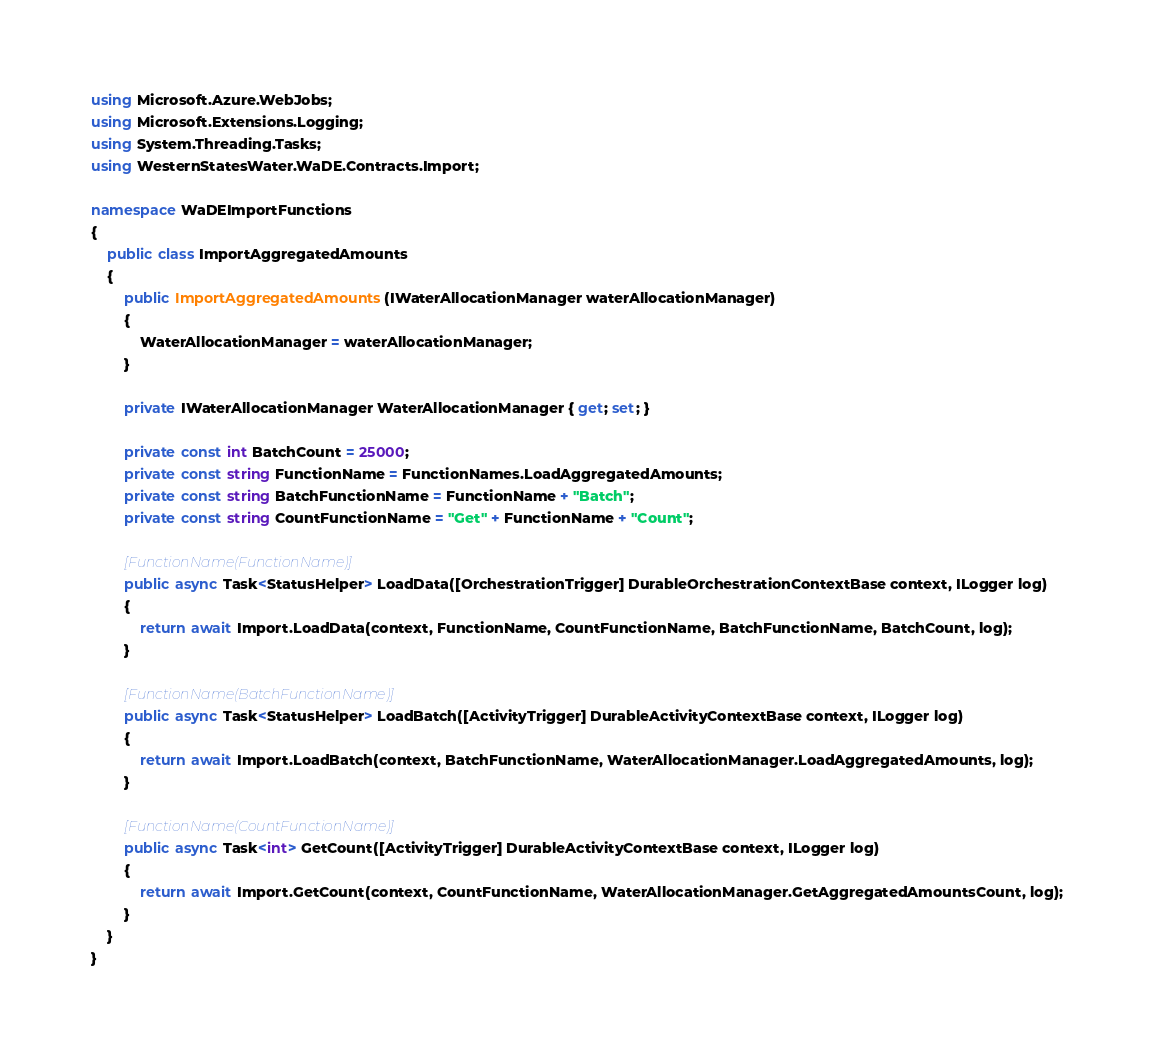Convert code to text. <code><loc_0><loc_0><loc_500><loc_500><_C#_>using Microsoft.Azure.WebJobs;
using Microsoft.Extensions.Logging;
using System.Threading.Tasks;
using WesternStatesWater.WaDE.Contracts.Import;

namespace WaDEImportFunctions
{
    public class ImportAggregatedAmounts
    {
        public ImportAggregatedAmounts(IWaterAllocationManager waterAllocationManager)
        {
            WaterAllocationManager = waterAllocationManager;
        }

        private IWaterAllocationManager WaterAllocationManager { get; set; }
        
        private const int BatchCount = 25000;
        private const string FunctionName = FunctionNames.LoadAggregatedAmounts;
        private const string BatchFunctionName = FunctionName + "Batch";
        private const string CountFunctionName = "Get" + FunctionName + "Count";

        [FunctionName(FunctionName)]
        public async Task<StatusHelper> LoadData([OrchestrationTrigger] DurableOrchestrationContextBase context, ILogger log)
        {
            return await Import.LoadData(context, FunctionName, CountFunctionName, BatchFunctionName, BatchCount, log);
        }

        [FunctionName(BatchFunctionName)]
        public async Task<StatusHelper> LoadBatch([ActivityTrigger] DurableActivityContextBase context, ILogger log)
        {
            return await Import.LoadBatch(context, BatchFunctionName, WaterAllocationManager.LoadAggregatedAmounts, log);
        }

        [FunctionName(CountFunctionName)]
        public async Task<int> GetCount([ActivityTrigger] DurableActivityContextBase context, ILogger log)
        {
            return await Import.GetCount(context, CountFunctionName, WaterAllocationManager.GetAggregatedAmountsCount, log);
        }
    }
}
</code> 